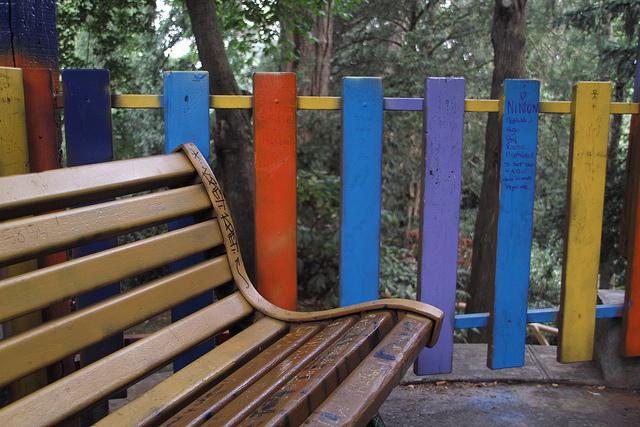Is that in a park?
Keep it brief. Yes. How many red boards?
Answer briefly. 1. Can we see what is to the right of the bench?
Quick response, please. No. 